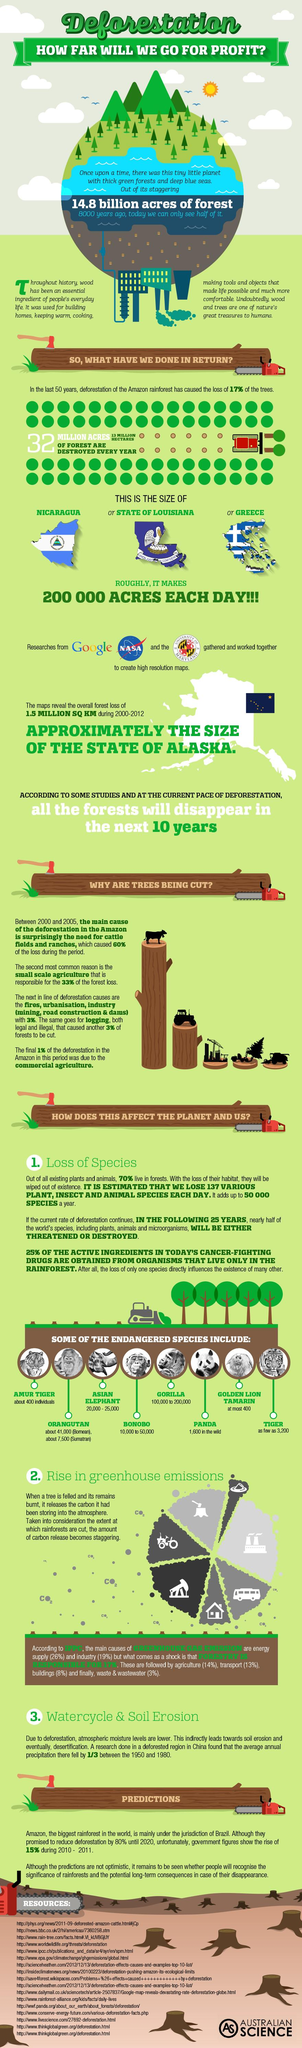Draw attention to some important aspects in this diagram. A recent study has found that 93% of forest loss can be attributed to the need for cattle farming and ranching, as well as small-scale agriculture. There are approximately 400 Golden Lion Tamarins in existence. Every year, approximately 32 million acres of forest are destroyed. The gorilla is the endangered species with the highest count. According to recent studies, agriculture, transport, and wastewater are the primary sources of greenhouse gas emissions, accounting for approximately 30% of the total emissions. 